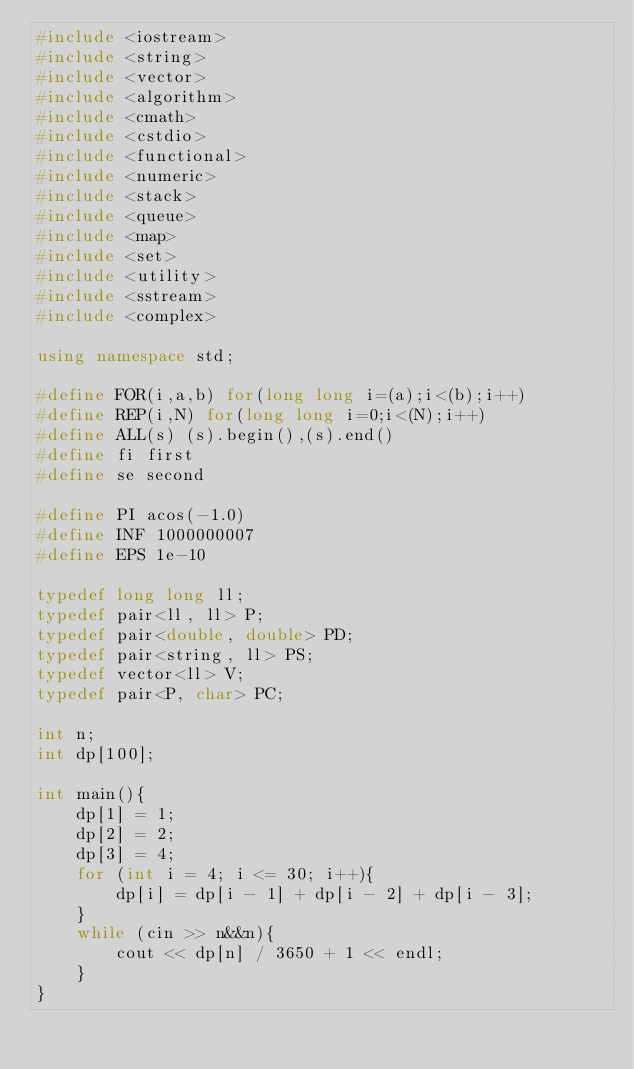Convert code to text. <code><loc_0><loc_0><loc_500><loc_500><_C++_>#include <iostream>
#include <string>
#include <vector>
#include <algorithm>
#include <cmath>
#include <cstdio>
#include <functional>
#include <numeric>
#include <stack>
#include <queue>
#include <map>
#include <set>
#include <utility>
#include <sstream>
#include <complex>

using namespace std;

#define FOR(i,a,b) for(long long i=(a);i<(b);i++)
#define REP(i,N) for(long long i=0;i<(N);i++)
#define ALL(s) (s).begin(),(s).end()
#define fi first
#define se second

#define PI acos(-1.0)
#define INF 1000000007
#define EPS 1e-10

typedef long long ll;
typedef pair<ll, ll> P;
typedef pair<double, double> PD;
typedef pair<string, ll> PS;
typedef vector<ll> V;
typedef pair<P, char> PC;

int n;
int dp[100];

int main(){
	dp[1] = 1;
	dp[2] = 2;
	dp[3] = 4;
	for (int i = 4; i <= 30; i++){
		dp[i] = dp[i - 1] + dp[i - 2] + dp[i - 3];
	}
	while (cin >> n&&n){
		cout << dp[n] / 3650 + 1 << endl;
	}
}</code> 